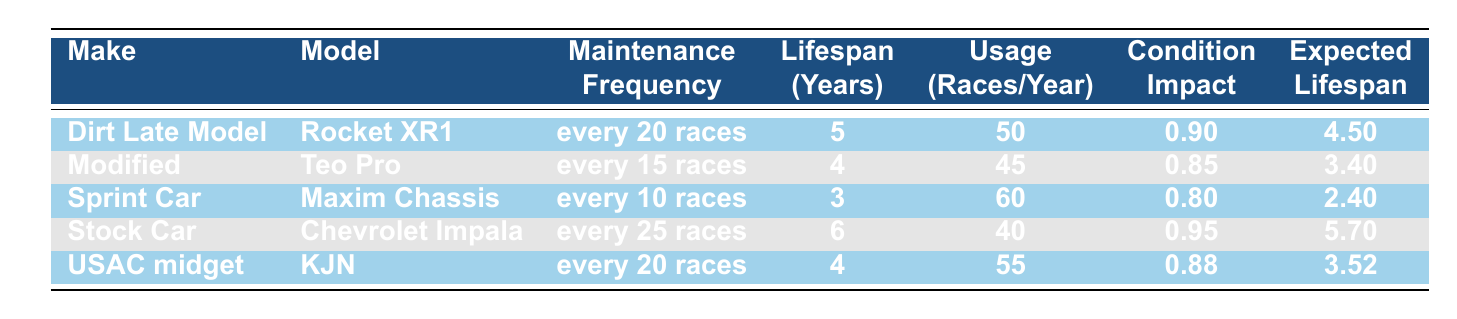What is the lifespan of the Sprint Car Maxim Chassis? The table lists the lifespan years for the Sprint Car Maxim Chassis, which shows it is 3 years.
Answer: 3 years How often does the Stock Car Chevrolet Impala require maintenance? According to the table, the Stock Car Chevrolet Impala requires maintenance every 25 races.
Answer: Every 25 races Which race car has the highest expected lifespan? Upon reviewing the Expected Lifespan column, the Stock Car Chevrolet Impala has the highest expected lifespan listed as 5.7 years.
Answer: 5.7 years What is the average lifespan of all the race cars listed? To find the average lifespan, sum the Lifespan Years: 5 + 4 + 3 + 6 + 4 = 22 years. There are 5 models, so the average is 22/5 = 4.4 years.
Answer: 4.4 years Is the expected lifespan of the Modified Teo Pro greater than that of the USAC midget KJN? By comparing the Expected Lifespan values from the table, the Modified Teo Pro has an expected lifespan of 3.4 years, while the USAC midget KJN has 3.52 years. Since 3.4 is less than 3.52, the answer is no.
Answer: No Which car's maintenance frequency is the most frequent? The Sprint Car Maxim Chassis requires maintenance every 10 races, which is more frequent compared to the others.
Answer: Every 10 races If you sum the expected lifespans of all the cars, what is the total? Adding the Expected Lifespans: 4.5 + 3.4 + 2.4 + 5.7 + 3.52 = 19.52 years.
Answer: 19.52 years Does the Dirt Late Model Rocket XR1 have a higher Condition Impact Factor than the Modified Teo Pro? The table shows that the Condition Impact Factor for the Dirt Late Model Rocket XR1 is 0.90, while the Modified Teo Pro's is 0.85. Since 0.90 is greater than 0.85, the answer is yes.
Answer: Yes What is the average number of races per year across all race cars? Summing the Average Usage Races Per Year: 50 + 45 + 60 + 40 + 55 = 250 races. Dividing by 5 cars gives an average of 250/5 = 50 races per year.
Answer: 50 races per year 